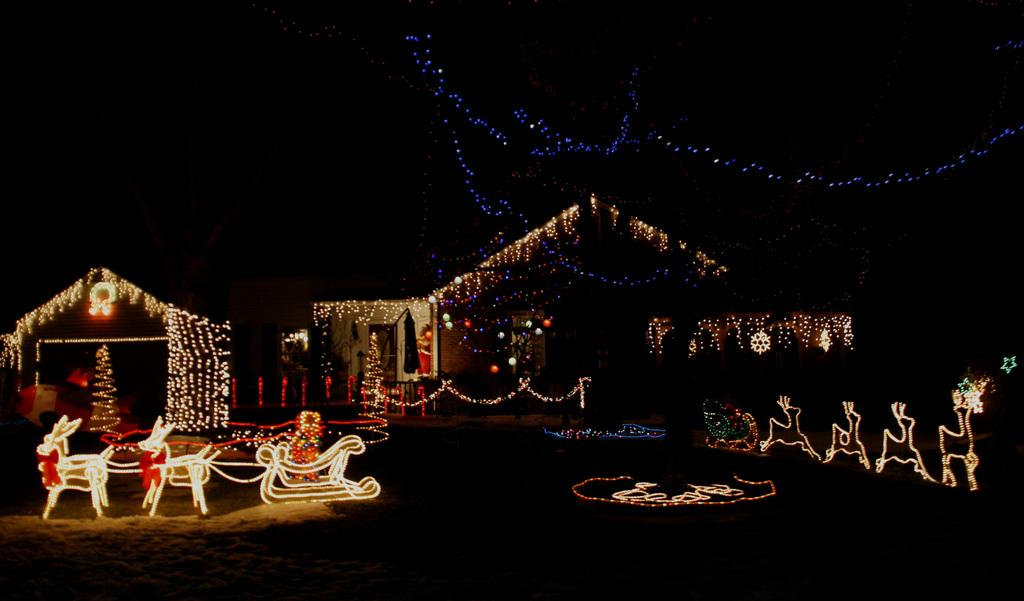What type of structures can be seen in the image? There are houses in the image. How are the houses decorated in the image? The houses are decorated with lights. Where are the lights located in the image? The lights are visible in the middle of the image. What type of blade is being used to cut the skirt in the image? There is no blade or skirt present in the image; it features houses decorated with lights. 